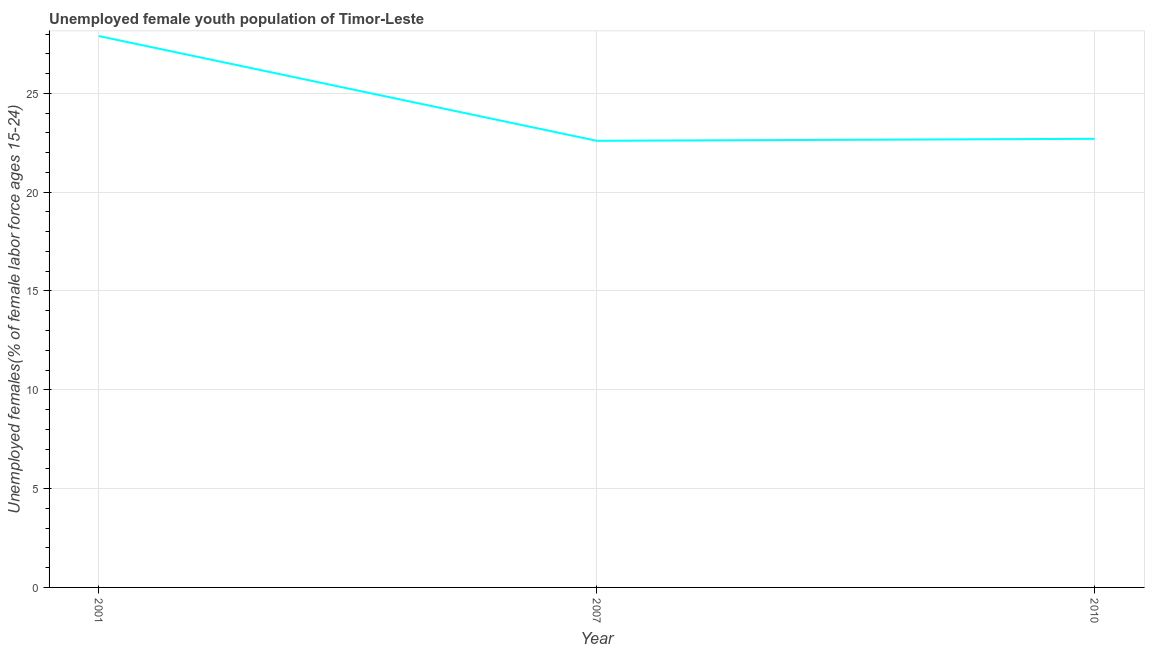What is the unemployed female youth in 2010?
Ensure brevity in your answer.  22.7. Across all years, what is the maximum unemployed female youth?
Offer a terse response. 27.9. Across all years, what is the minimum unemployed female youth?
Make the answer very short. 22.6. What is the sum of the unemployed female youth?
Offer a terse response. 73.2. What is the difference between the unemployed female youth in 2007 and 2010?
Make the answer very short. -0.1. What is the average unemployed female youth per year?
Keep it short and to the point. 24.4. What is the median unemployed female youth?
Keep it short and to the point. 22.7. In how many years, is the unemployed female youth greater than 7 %?
Ensure brevity in your answer.  3. What is the ratio of the unemployed female youth in 2001 to that in 2007?
Your answer should be compact. 1.23. Is the unemployed female youth in 2001 less than that in 2007?
Your response must be concise. No. What is the difference between the highest and the second highest unemployed female youth?
Offer a terse response. 5.2. Is the sum of the unemployed female youth in 2001 and 2010 greater than the maximum unemployed female youth across all years?
Provide a succinct answer. Yes. What is the difference between the highest and the lowest unemployed female youth?
Make the answer very short. 5.3. In how many years, is the unemployed female youth greater than the average unemployed female youth taken over all years?
Provide a succinct answer. 1. How many years are there in the graph?
Your response must be concise. 3. Does the graph contain grids?
Keep it short and to the point. Yes. What is the title of the graph?
Provide a short and direct response. Unemployed female youth population of Timor-Leste. What is the label or title of the X-axis?
Your response must be concise. Year. What is the label or title of the Y-axis?
Offer a very short reply. Unemployed females(% of female labor force ages 15-24). What is the Unemployed females(% of female labor force ages 15-24) in 2001?
Offer a terse response. 27.9. What is the Unemployed females(% of female labor force ages 15-24) in 2007?
Give a very brief answer. 22.6. What is the Unemployed females(% of female labor force ages 15-24) in 2010?
Provide a succinct answer. 22.7. What is the difference between the Unemployed females(% of female labor force ages 15-24) in 2001 and 2010?
Ensure brevity in your answer.  5.2. What is the ratio of the Unemployed females(% of female labor force ages 15-24) in 2001 to that in 2007?
Provide a short and direct response. 1.24. What is the ratio of the Unemployed females(% of female labor force ages 15-24) in 2001 to that in 2010?
Your response must be concise. 1.23. 